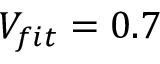Convert formula to latex. <formula><loc_0><loc_0><loc_500><loc_500>V _ { f i t } = 0 . 7</formula> 